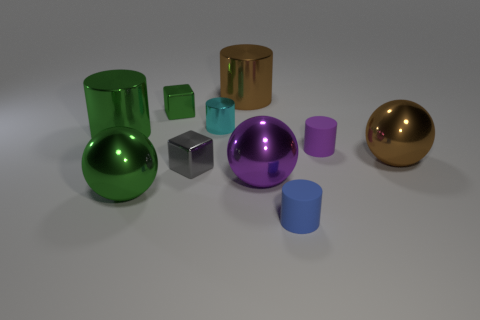What material is the cyan cylinder?
Provide a short and direct response. Metal. What is the material of the small thing that is on the right side of the big purple metallic object and behind the blue rubber thing?
Provide a succinct answer. Rubber. How many small objects are either brown shiny balls or brown things?
Your answer should be very brief. 0. The purple matte cylinder is what size?
Your answer should be very brief. Small. What is the shape of the cyan thing?
Offer a terse response. Cylinder. Is there anything else that is the same shape as the purple rubber thing?
Offer a terse response. Yes. Are there fewer shiny cubes that are on the right side of the green cube than large metallic cylinders?
Provide a succinct answer. Yes. Is the color of the cube that is in front of the large green metallic cylinder the same as the small metal cylinder?
Your response must be concise. No. What number of shiny objects are either cylinders or big balls?
Your answer should be compact. 6. What color is the tiny cylinder that is made of the same material as the big purple sphere?
Your answer should be compact. Cyan. 